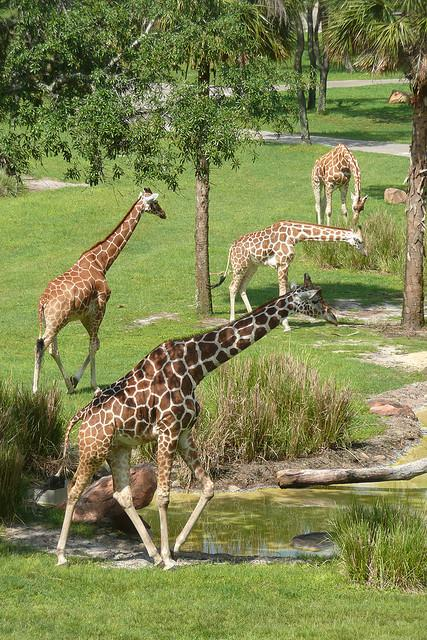What does the animal in the foreground have? spots 